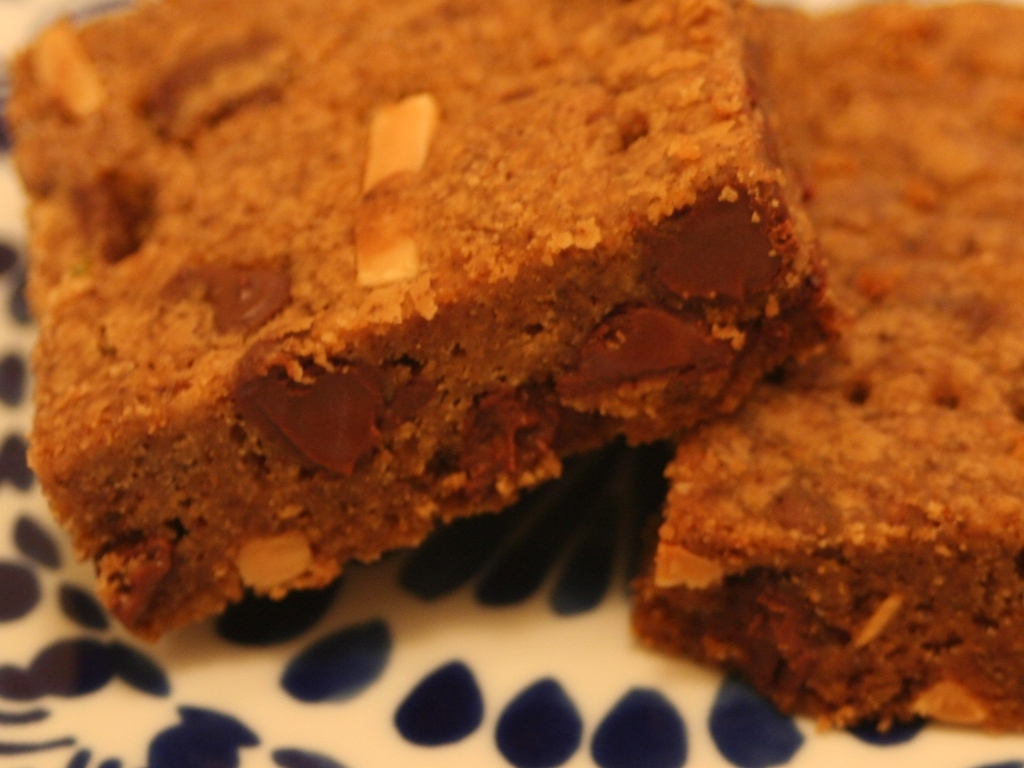Is the overall lighting of the image sufficient? Yes, the overall lighting of the image is sufficient as it allows for the details of the chocolate chips and texture of the brownies to be clearly visible, revealing a rich and tempting treat. 